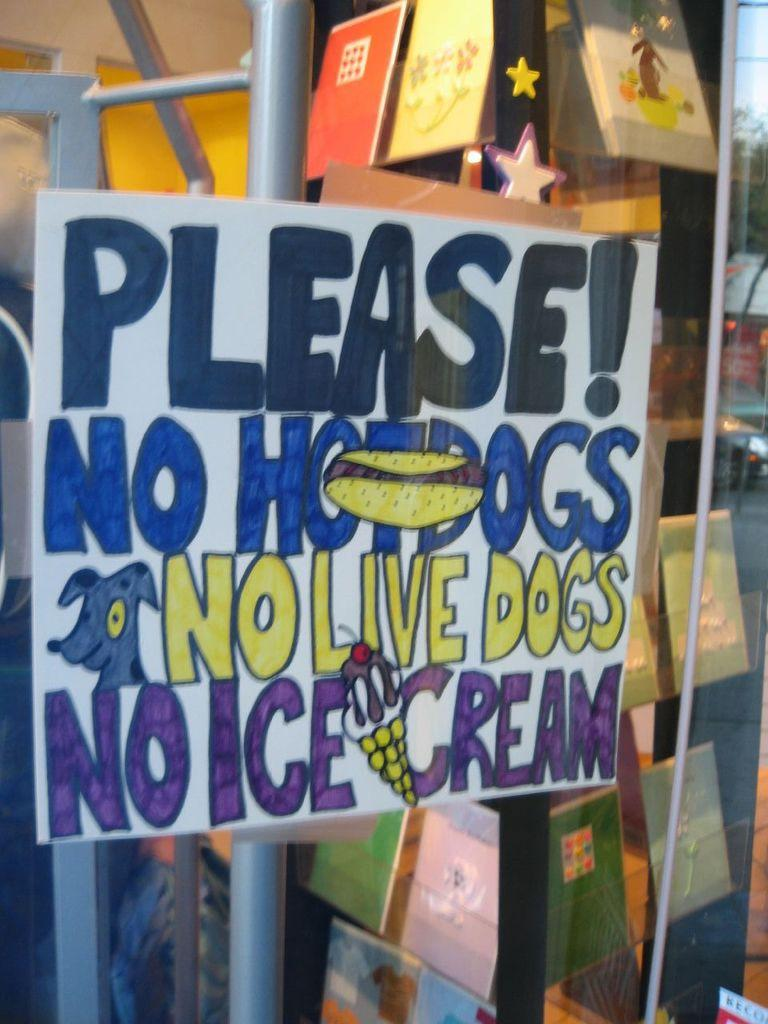Provide a one-sentence caption for the provided image. Large sign on a store that says "Please! No hotdogs No Live Dogs No Ice Cream". 